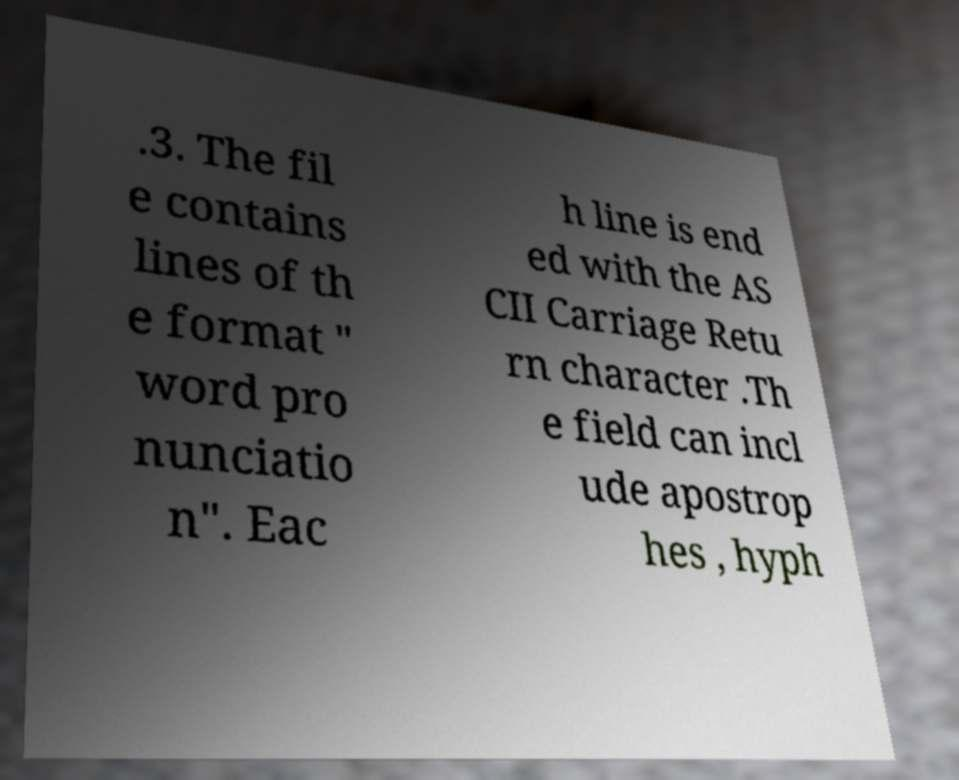Can you accurately transcribe the text from the provided image for me? .3. The fil e contains lines of th e format " word pro nunciatio n". Eac h line is end ed with the AS CII Carriage Retu rn character .Th e field can incl ude apostrop hes , hyph 